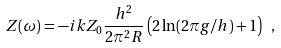<formula> <loc_0><loc_0><loc_500><loc_500>Z ( \omega ) = - i k Z _ { 0 } \frac { h ^ { 2 } } { 2 \pi ^ { 2 } R } \left ( 2 \ln ( 2 \pi g / h ) + 1 \right ) \ ,</formula> 